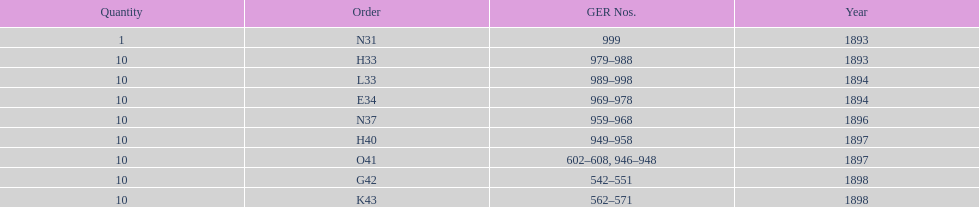What is the total number of locomotives made during this time? 81. 